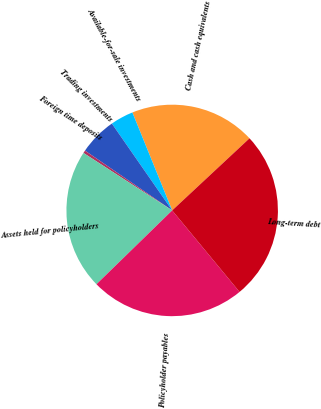<chart> <loc_0><loc_0><loc_500><loc_500><pie_chart><fcel>Cash and cash equivalents<fcel>Available-for-sale investments<fcel>Trading investments<fcel>Foreign time deposits<fcel>Assets held for policyholders<fcel>Policyholder payables<fcel>Long-term debt<nl><fcel>19.2%<fcel>3.52%<fcel>5.77%<fcel>0.42%<fcel>21.45%<fcel>23.7%<fcel>25.95%<nl></chart> 